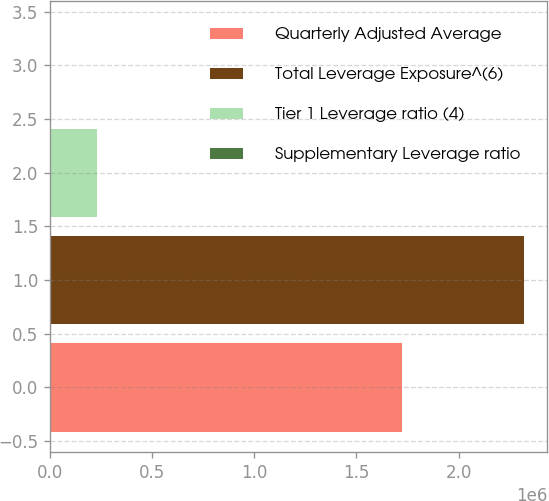Convert chart to OTSL. <chart><loc_0><loc_0><loc_500><loc_500><bar_chart><fcel>Quarterly Adjusted Average<fcel>Total Leverage Exposure^(6)<fcel>Tier 1 Leverage ratio (4)<fcel>Supplementary Leverage ratio<nl><fcel>1.72471e+06<fcel>2.31785e+06<fcel>231791<fcel>7.08<nl></chart> 